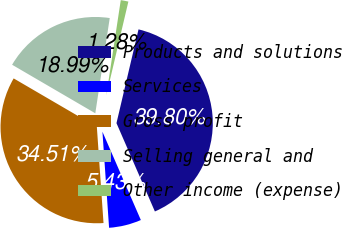<chart> <loc_0><loc_0><loc_500><loc_500><pie_chart><fcel>Products and solutions<fcel>Services<fcel>Gross profit<fcel>Selling general and<fcel>Other income (expense)<nl><fcel>39.8%<fcel>5.43%<fcel>34.51%<fcel>18.99%<fcel>1.28%<nl></chart> 